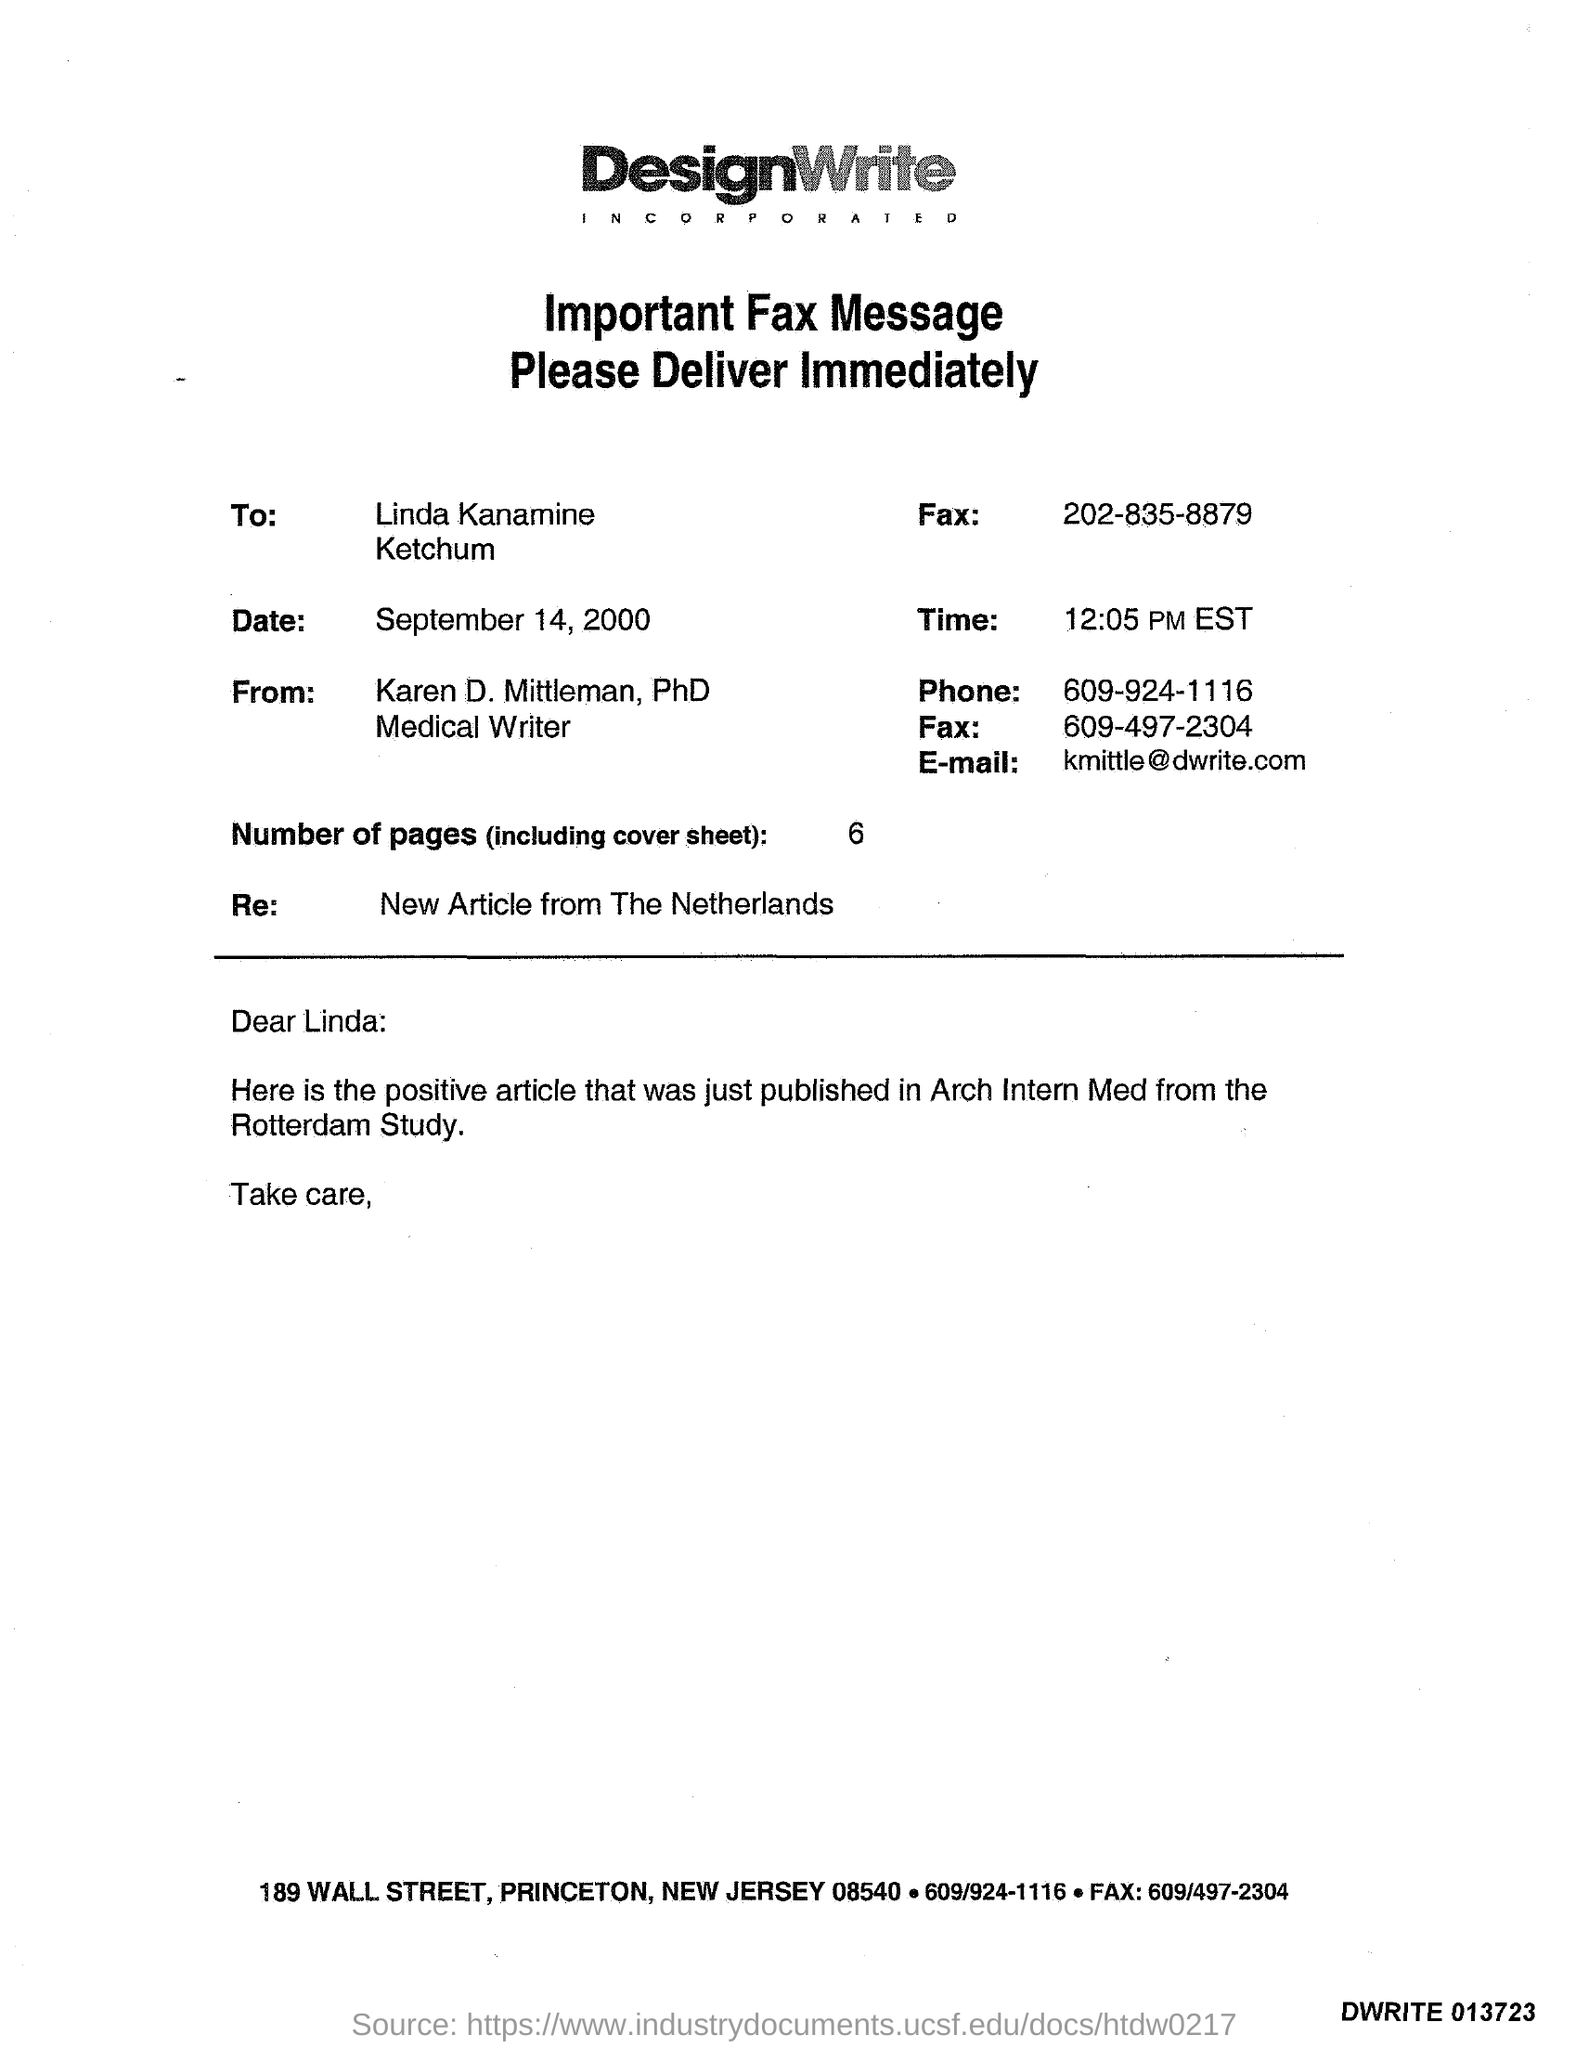What is the E-mail Id of Karen D. Mittleman?
Offer a very short reply. Kmittle@dwrite.com. 